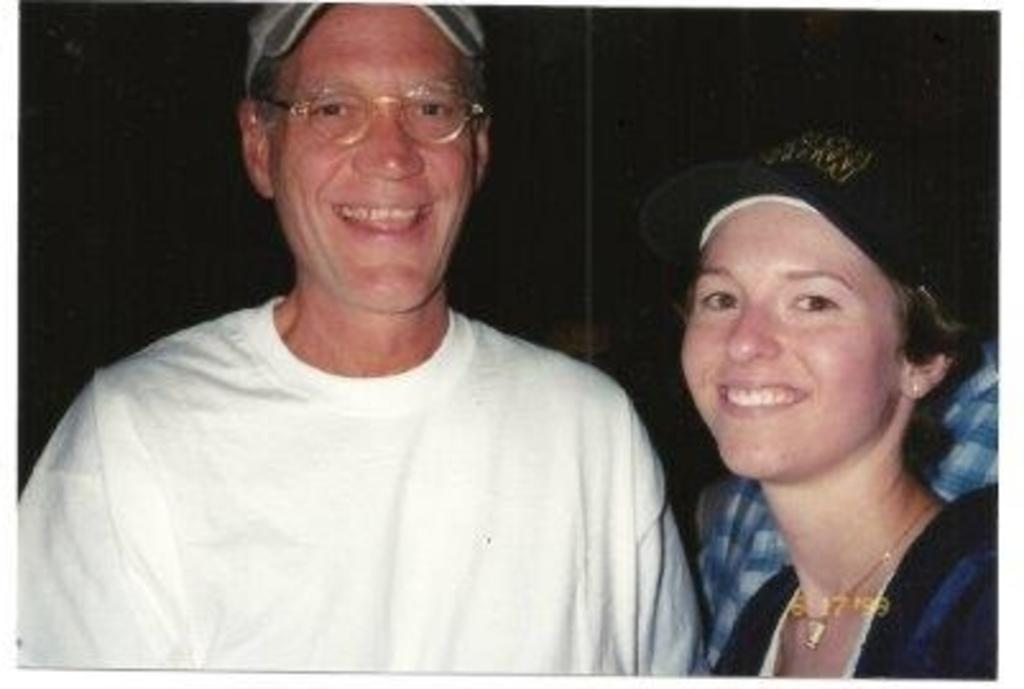Who is present on the left side of the image? There is a man on the left side of the image. Who is present on the right side of the image? There is a girl on the right side of the image. What is the man wearing on his head? The man is wearing a cap. What is the man wearing on his face? The man is wearing spectacles. What type of lettuce is the man holding in the image? There is no lettuce present in the image; the man is not holding any lettuce. 